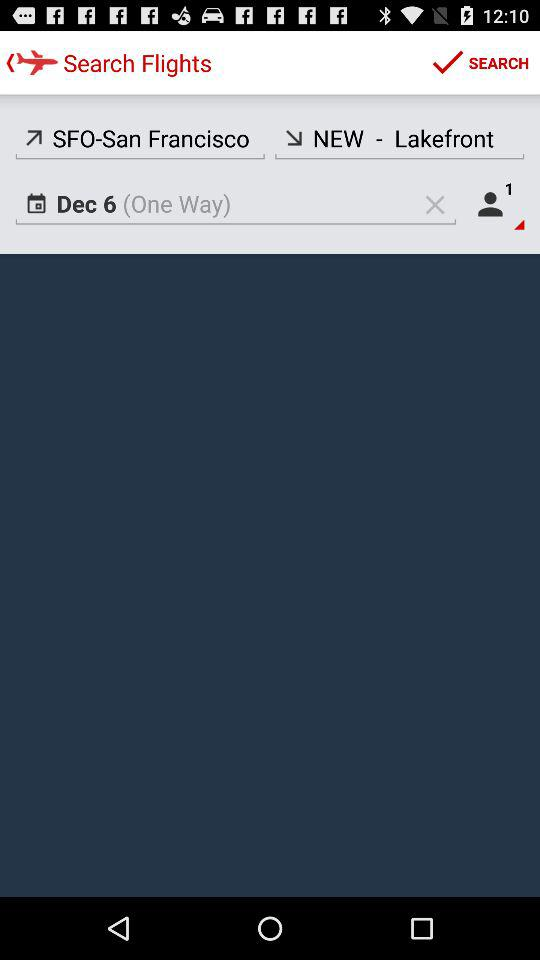What's the arrival location? The arrival location is NEW - Lakefront. 